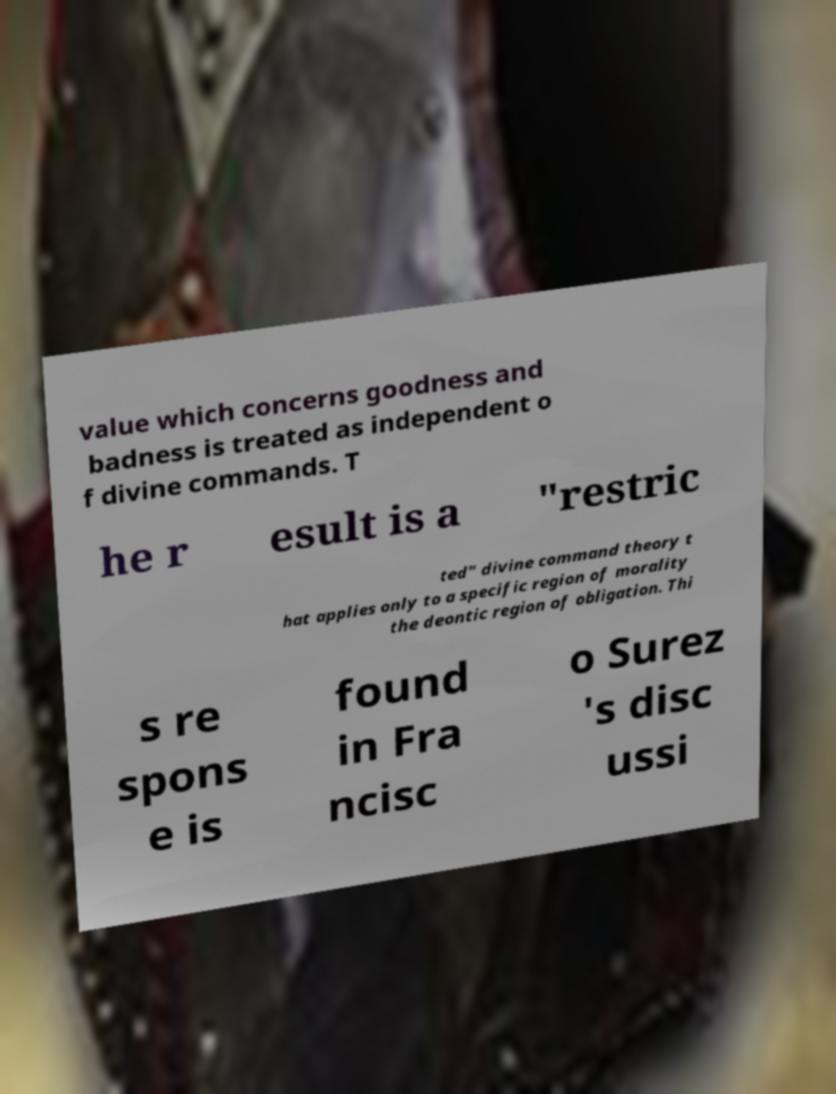Please read and relay the text visible in this image. What does it say? value which concerns goodness and badness is treated as independent o f divine commands. T he r esult is a "restric ted" divine command theory t hat applies only to a specific region of morality the deontic region of obligation. Thi s re spons e is found in Fra ncisc o Surez 's disc ussi 